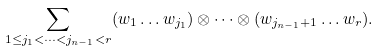Convert formula to latex. <formula><loc_0><loc_0><loc_500><loc_500>\sum _ { 1 \leq j _ { 1 } < \dots < j _ { n - 1 } < r } ( w _ { 1 } \dots w _ { j _ { 1 } } ) \otimes \dots \otimes ( w _ { j _ { n - 1 } + 1 } \dots w _ { r } ) .</formula> 